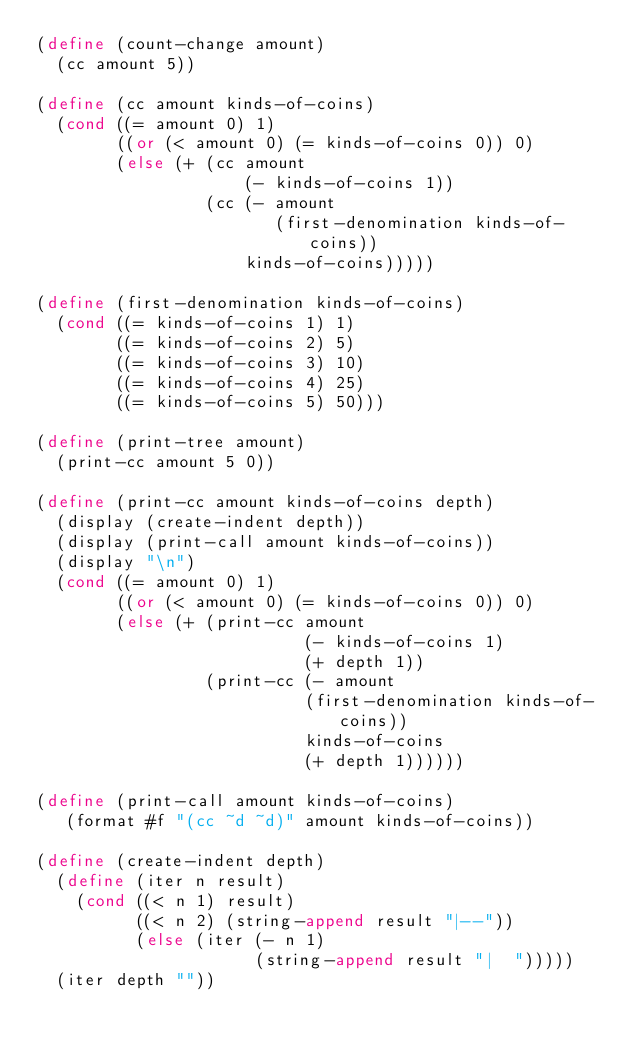<code> <loc_0><loc_0><loc_500><loc_500><_Scheme_>(define (count-change amount)
  (cc amount 5))

(define (cc amount kinds-of-coins)
  (cond ((= amount 0) 1)
        ((or (< amount 0) (= kinds-of-coins 0)) 0)
        (else (+ (cc amount
                     (- kinds-of-coins 1))
                 (cc (- amount
                        (first-denomination kinds-of-coins))
                     kinds-of-coins)))))

(define (first-denomination kinds-of-coins)
  (cond ((= kinds-of-coins 1) 1)
        ((= kinds-of-coins 2) 5)
        ((= kinds-of-coins 3) 10)
        ((= kinds-of-coins 4) 25)
        ((= kinds-of-coins 5) 50)))

(define (print-tree amount)
  (print-cc amount 5 0))

(define (print-cc amount kinds-of-coins depth)
  (display (create-indent depth))
  (display (print-call amount kinds-of-coins))
  (display "\n")
  (cond ((= amount 0) 1)
        ((or (< amount 0) (= kinds-of-coins 0)) 0)
        (else (+ (print-cc amount
                           (- kinds-of-coins 1)
                           (+ depth 1))
                 (print-cc (- amount
                           (first-denomination kinds-of-coins))
                           kinds-of-coins
                           (+ depth 1))))))

(define (print-call amount kinds-of-coins)
   (format #f "(cc ~d ~d)" amount kinds-of-coins))

(define (create-indent depth)
  (define (iter n result)
    (cond ((< n 1) result)
          ((< n 2) (string-append result "|--"))
          (else (iter (- n 1)
                      (string-append result "|  ")))))
  (iter depth ""))
</code> 